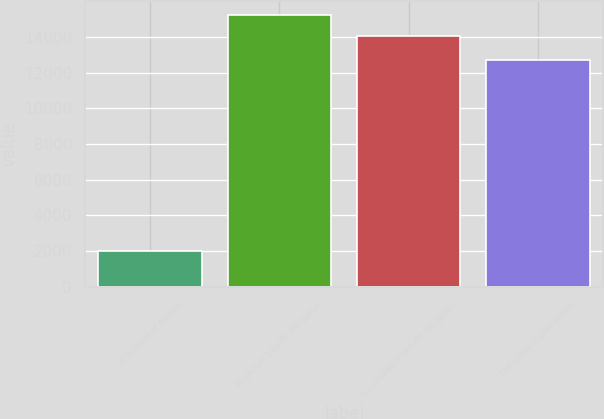Convert chart. <chart><loc_0><loc_0><loc_500><loc_500><bar_chart><fcel>In millions of dollars<fcel>Projected benefit obligation<fcel>Accumulated benefit obligation<fcel>Fair value of plan assets<nl><fcel>2017<fcel>15236.3<fcel>14034<fcel>12725<nl></chart> 